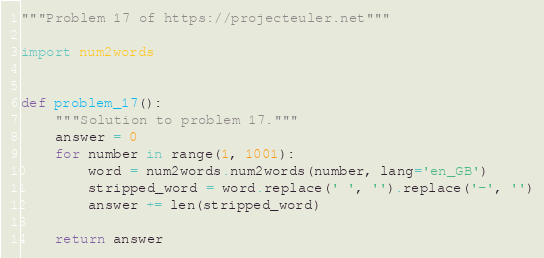Convert code to text. <code><loc_0><loc_0><loc_500><loc_500><_Python_>"""Problem 17 of https://projecteuler.net"""

import num2words


def problem_17():
    """Solution to problem 17."""
    answer = 0
    for number in range(1, 1001):
        word = num2words.num2words(number, lang='en_GB')
        stripped_word = word.replace(' ', '').replace('-', '')
        answer += len(stripped_word)

    return answer
</code> 